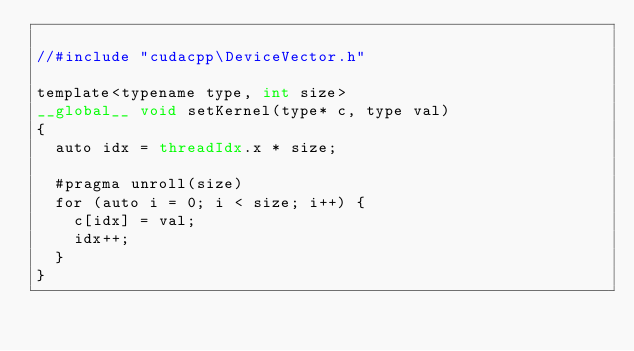<code> <loc_0><loc_0><loc_500><loc_500><_Cuda_>
//#include "cudacpp\DeviceVector.h"

template<typename type, int size>
__global__ void setKernel(type* c, type val)
{
	auto idx = threadIdx.x * size;

	#pragma unroll(size)
	for (auto i = 0; i < size; i++) {
		c[idx] = val;
		idx++;
	}
}</code> 